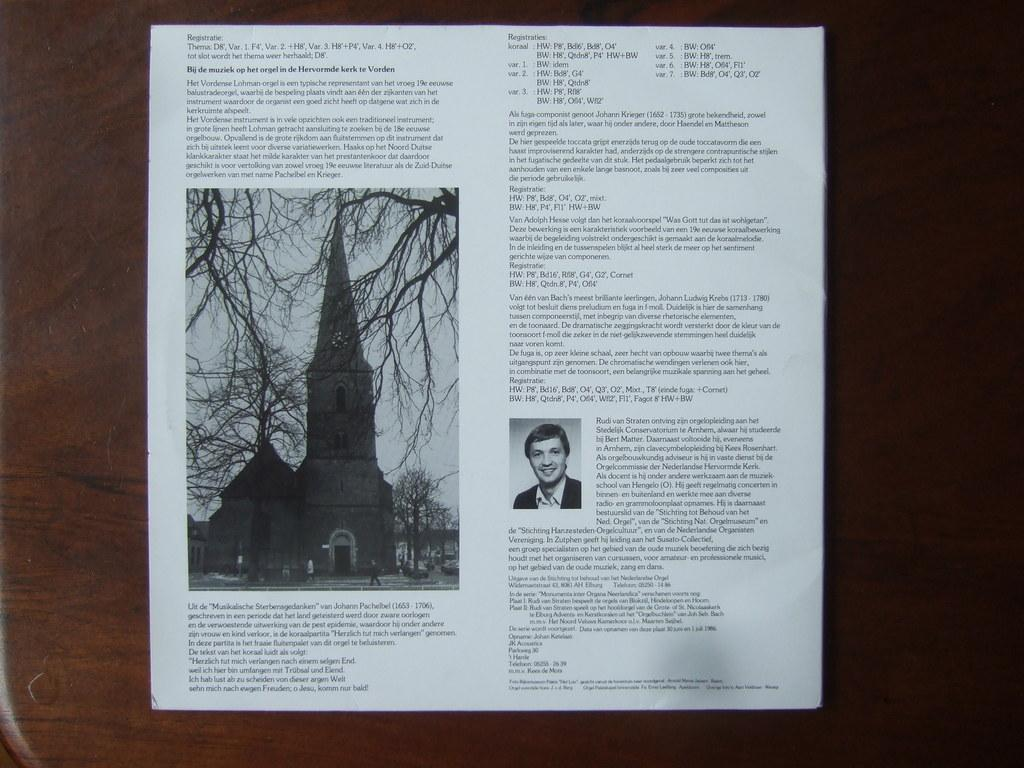What is on the wooden surface in the image? There is a paper present on the wooden surface in the image. What can be found on the paper? The paper contains pictures and text. How many balls are visible on the paper in the image? There are no balls visible on the paper in the image. What role does the father play in the image? There is no mention of a father or any person in the image, so it is not possible to answer this question. 